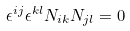Convert formula to latex. <formula><loc_0><loc_0><loc_500><loc_500>\epsilon ^ { i j } \epsilon ^ { k l } N _ { i k } N _ { j l } = 0</formula> 